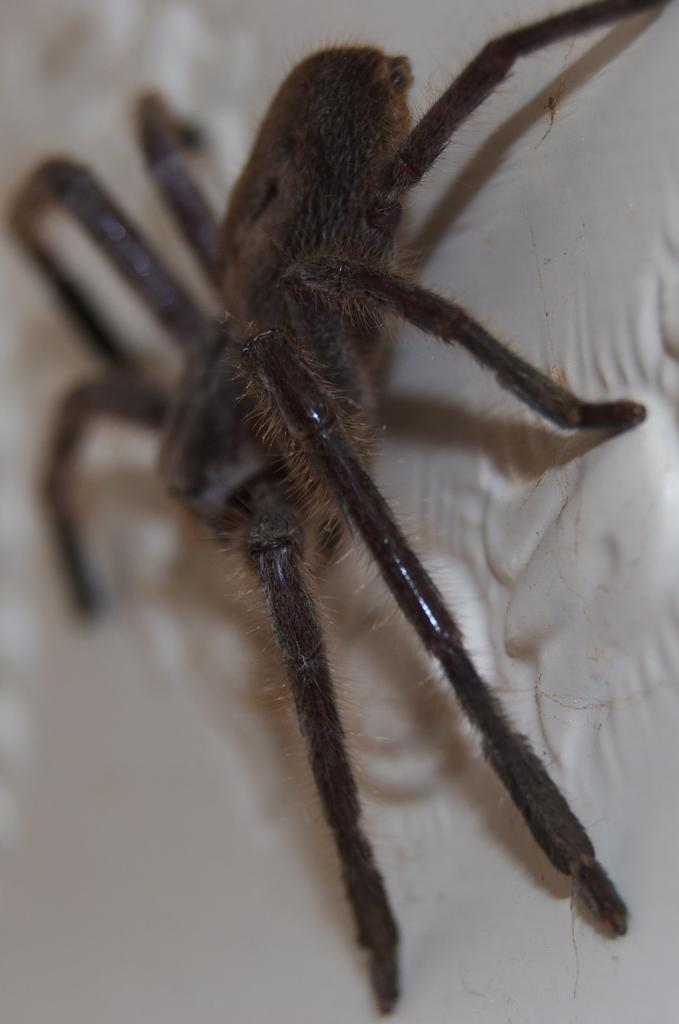What is the main subject of the image? There is a spider in the image. What color is the spider? The spider is black in color. What can be observed about the background of the image? The background of the image is white, and it may be a wall or a sheet. How is the background of the image depicted? The background is blurred. What type of steel structure can be seen in the image? There is no steel structure present in the image; it features a black spider against a white background. 